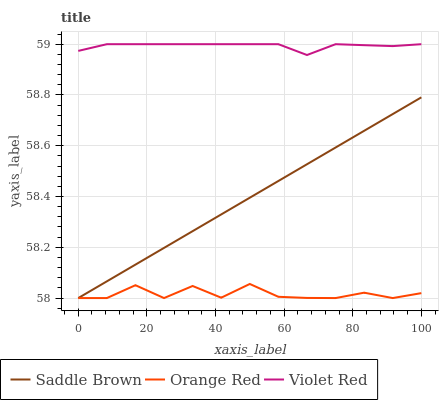Does Saddle Brown have the minimum area under the curve?
Answer yes or no. No. Does Saddle Brown have the maximum area under the curve?
Answer yes or no. No. Is Orange Red the smoothest?
Answer yes or no. No. Is Saddle Brown the roughest?
Answer yes or no. No. Does Saddle Brown have the highest value?
Answer yes or no. No. Is Saddle Brown less than Violet Red?
Answer yes or no. Yes. Is Violet Red greater than Orange Red?
Answer yes or no. Yes. Does Saddle Brown intersect Violet Red?
Answer yes or no. No. 